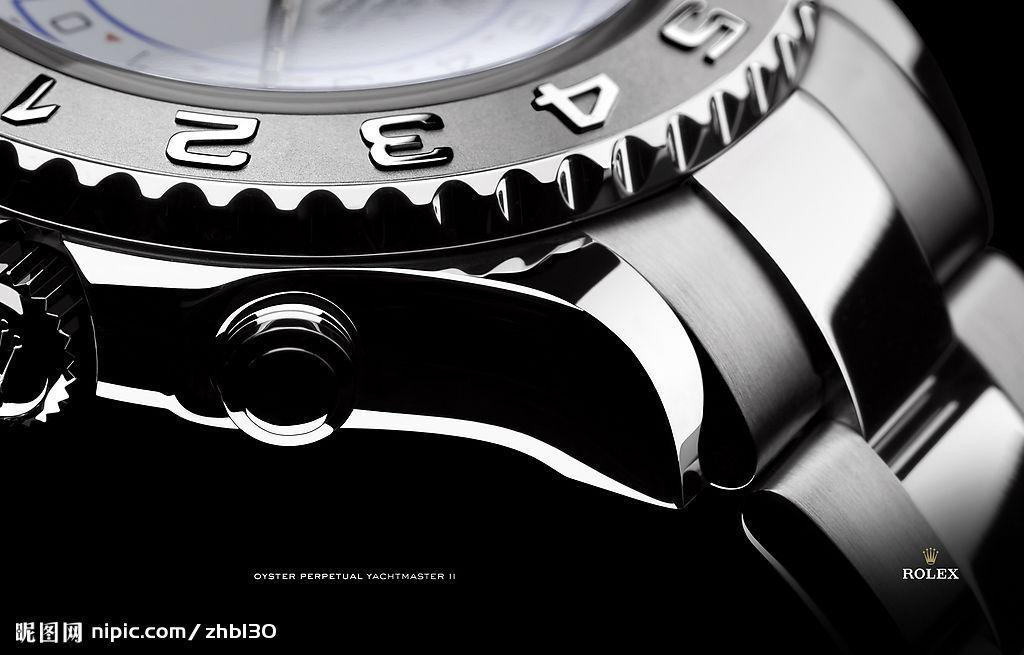<image>
Summarize the visual content of the image. Close up of a Rolex wtch and part of the band. 